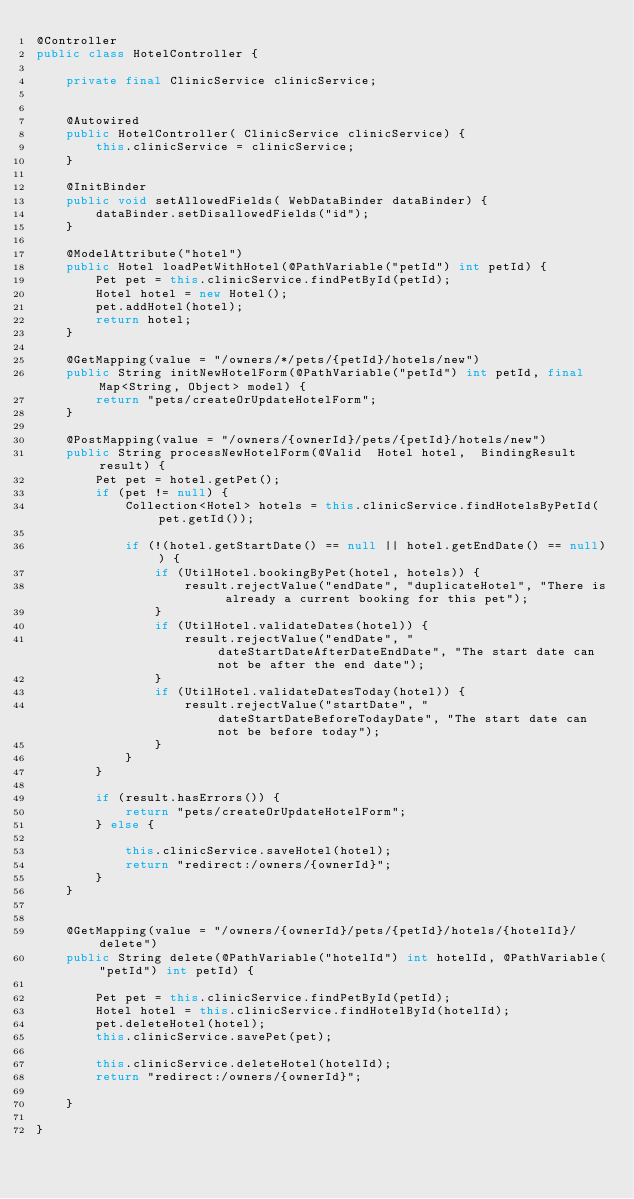Convert code to text. <code><loc_0><loc_0><loc_500><loc_500><_Java_>@Controller
public class HotelController {

	private final ClinicService clinicService;


	@Autowired
	public HotelController( ClinicService clinicService) {
		this.clinicService = clinicService;
	}

	@InitBinder
	public void setAllowedFields( WebDataBinder dataBinder) {
		dataBinder.setDisallowedFields("id");
	}

	@ModelAttribute("hotel")
	public Hotel loadPetWithHotel(@PathVariable("petId") int petId) {
		Pet pet = this.clinicService.findPetById(petId);
		Hotel hotel = new Hotel();
		pet.addHotel(hotel);
		return hotel;
	}

	@GetMapping(value = "/owners/*/pets/{petId}/hotels/new")
	public String initNewHotelForm(@PathVariable("petId") int petId, final Map<String, Object> model) {
		return "pets/createOrUpdateHotelForm";
	}

	@PostMapping(value = "/owners/{ownerId}/pets/{petId}/hotels/new")
	public String processNewHotelForm(@Valid  Hotel hotel,  BindingResult result) {
		Pet pet = hotel.getPet();
		if (pet != null) {
			Collection<Hotel> hotels = this.clinicService.findHotelsByPetId(pet.getId());

			if (!(hotel.getStartDate() == null || hotel.getEndDate() == null)) {
				if (UtilHotel.bookingByPet(hotel, hotels)) {
					result.rejectValue("endDate", "duplicateHotel", "There is already a current booking for this pet");
				}
				if (UtilHotel.validateDates(hotel)) {
					result.rejectValue("endDate", "dateStartDateAfterDateEndDate", "The start date can not be after the end date");
				}
				if (UtilHotel.validateDatesToday(hotel)) {
					result.rejectValue("startDate", "dateStartDateBeforeTodayDate", "The start date can not be before today");
				}
			}
		}

		if (result.hasErrors()) {
			return "pets/createOrUpdateHotelForm";
		} else {

			this.clinicService.saveHotel(hotel);
			return "redirect:/owners/{ownerId}";
		}
	}
	

	@GetMapping(value = "/owners/{ownerId}/pets/{petId}/hotels/{hotelId}/delete")
	public String delete(@PathVariable("hotelId") int hotelId, @PathVariable("petId") int petId) {

		Pet pet = this.clinicService.findPetById(petId);
		Hotel hotel = this.clinicService.findHotelById(hotelId);
		pet.deleteHotel(hotel);
		this.clinicService.savePet(pet);

		this.clinicService.deleteHotel(hotelId);
		return "redirect:/owners/{ownerId}";

	}

}
</code> 